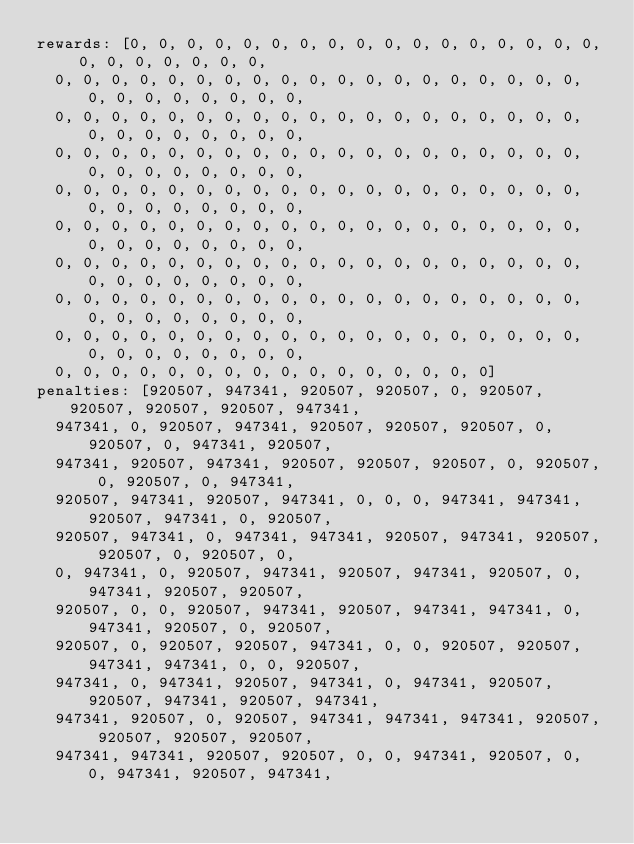<code> <loc_0><loc_0><loc_500><loc_500><_YAML_>rewards: [0, 0, 0, 0, 0, 0, 0, 0, 0, 0, 0, 0, 0, 0, 0, 0, 0, 0, 0, 0, 0, 0, 0, 0,
  0, 0, 0, 0, 0, 0, 0, 0, 0, 0, 0, 0, 0, 0, 0, 0, 0, 0, 0, 0, 0, 0, 0, 0, 0, 0, 0,
  0, 0, 0, 0, 0, 0, 0, 0, 0, 0, 0, 0, 0, 0, 0, 0, 0, 0, 0, 0, 0, 0, 0, 0, 0, 0, 0,
  0, 0, 0, 0, 0, 0, 0, 0, 0, 0, 0, 0, 0, 0, 0, 0, 0, 0, 0, 0, 0, 0, 0, 0, 0, 0, 0,
  0, 0, 0, 0, 0, 0, 0, 0, 0, 0, 0, 0, 0, 0, 0, 0, 0, 0, 0, 0, 0, 0, 0, 0, 0, 0, 0,
  0, 0, 0, 0, 0, 0, 0, 0, 0, 0, 0, 0, 0, 0, 0, 0, 0, 0, 0, 0, 0, 0, 0, 0, 0, 0, 0,
  0, 0, 0, 0, 0, 0, 0, 0, 0, 0, 0, 0, 0, 0, 0, 0, 0, 0, 0, 0, 0, 0, 0, 0, 0, 0, 0,
  0, 0, 0, 0, 0, 0, 0, 0, 0, 0, 0, 0, 0, 0, 0, 0, 0, 0, 0, 0, 0, 0, 0, 0, 0, 0, 0,
  0, 0, 0, 0, 0, 0, 0, 0, 0, 0, 0, 0, 0, 0, 0, 0, 0, 0, 0, 0, 0, 0, 0, 0, 0, 0, 0,
  0, 0, 0, 0, 0, 0, 0, 0, 0, 0, 0, 0, 0, 0, 0, 0]
penalties: [920507, 947341, 920507, 920507, 0, 920507, 920507, 920507, 920507, 947341,
  947341, 0, 920507, 947341, 920507, 920507, 920507, 0, 920507, 0, 947341, 920507,
  947341, 920507, 947341, 920507, 920507, 920507, 0, 920507, 0, 920507, 0, 947341,
  920507, 947341, 920507, 947341, 0, 0, 0, 947341, 947341, 920507, 947341, 0, 920507,
  920507, 947341, 0, 947341, 947341, 920507, 947341, 920507, 920507, 0, 920507, 0,
  0, 947341, 0, 920507, 947341, 920507, 947341, 920507, 0, 947341, 920507, 920507,
  920507, 0, 0, 920507, 947341, 920507, 947341, 947341, 0, 947341, 920507, 0, 920507,
  920507, 0, 920507, 920507, 947341, 0, 0, 920507, 920507, 947341, 947341, 0, 0, 920507,
  947341, 0, 947341, 920507, 947341, 0, 947341, 920507, 920507, 947341, 920507, 947341,
  947341, 920507, 0, 920507, 947341, 947341, 947341, 920507, 920507, 920507, 920507,
  947341, 947341, 920507, 920507, 0, 0, 947341, 920507, 0, 0, 947341, 920507, 947341,</code> 